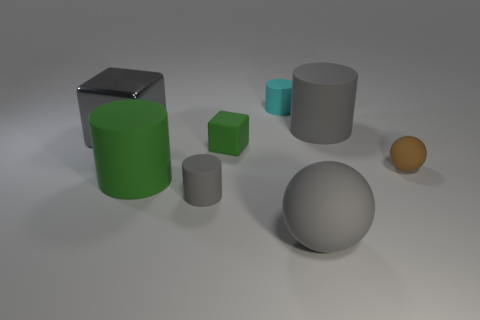What number of cyan objects are either rubber objects or small cylinders?
Your answer should be very brief. 1. Do the brown object and the cyan object on the left side of the small brown thing have the same material?
Give a very brief answer. Yes. Are there an equal number of small matte cubes behind the big metal thing and cyan matte objects left of the cyan thing?
Your answer should be very brief. Yes. There is a brown matte object; is it the same size as the gray cylinder that is in front of the big shiny cube?
Keep it short and to the point. Yes. Are there more small matte cylinders that are in front of the tiny green thing than small cyan rubber cylinders?
Provide a succinct answer. No. What number of green blocks are the same size as the gray sphere?
Your response must be concise. 0. There is a gray rubber cylinder that is right of the cyan object; is it the same size as the gray metal cube that is in front of the cyan rubber thing?
Ensure brevity in your answer.  Yes. Are there more cyan cylinders that are on the right side of the tiny brown rubber ball than large spheres behind the gray metallic cube?
Your answer should be compact. No. How many brown rubber objects are the same shape as the tiny cyan matte thing?
Keep it short and to the point. 0. What material is the gray ball that is the same size as the green rubber cylinder?
Provide a short and direct response. Rubber. 